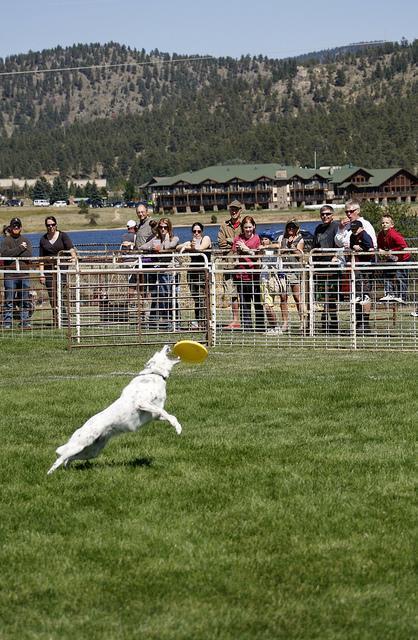Approximately how many people are watching the event?
Indicate the correct choice and explain in the format: 'Answer: answer
Rationale: rationale.'
Options: Hundreds, thousands, dozen, two. Answer: dozen.
Rationale: There is a small crowd of about 12 people watching the event. 